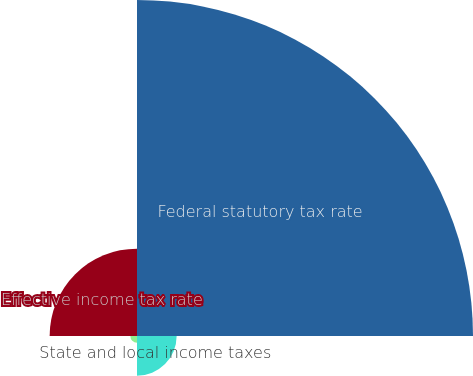Convert chart to OTSL. <chart><loc_0><loc_0><loc_500><loc_500><pie_chart><fcel>Federal statutory tax rate<fcel>State and local income taxes<fcel>Other net<fcel>Effective income tax rate<nl><fcel>71.53%<fcel>8.44%<fcel>1.43%<fcel>18.6%<nl></chart> 